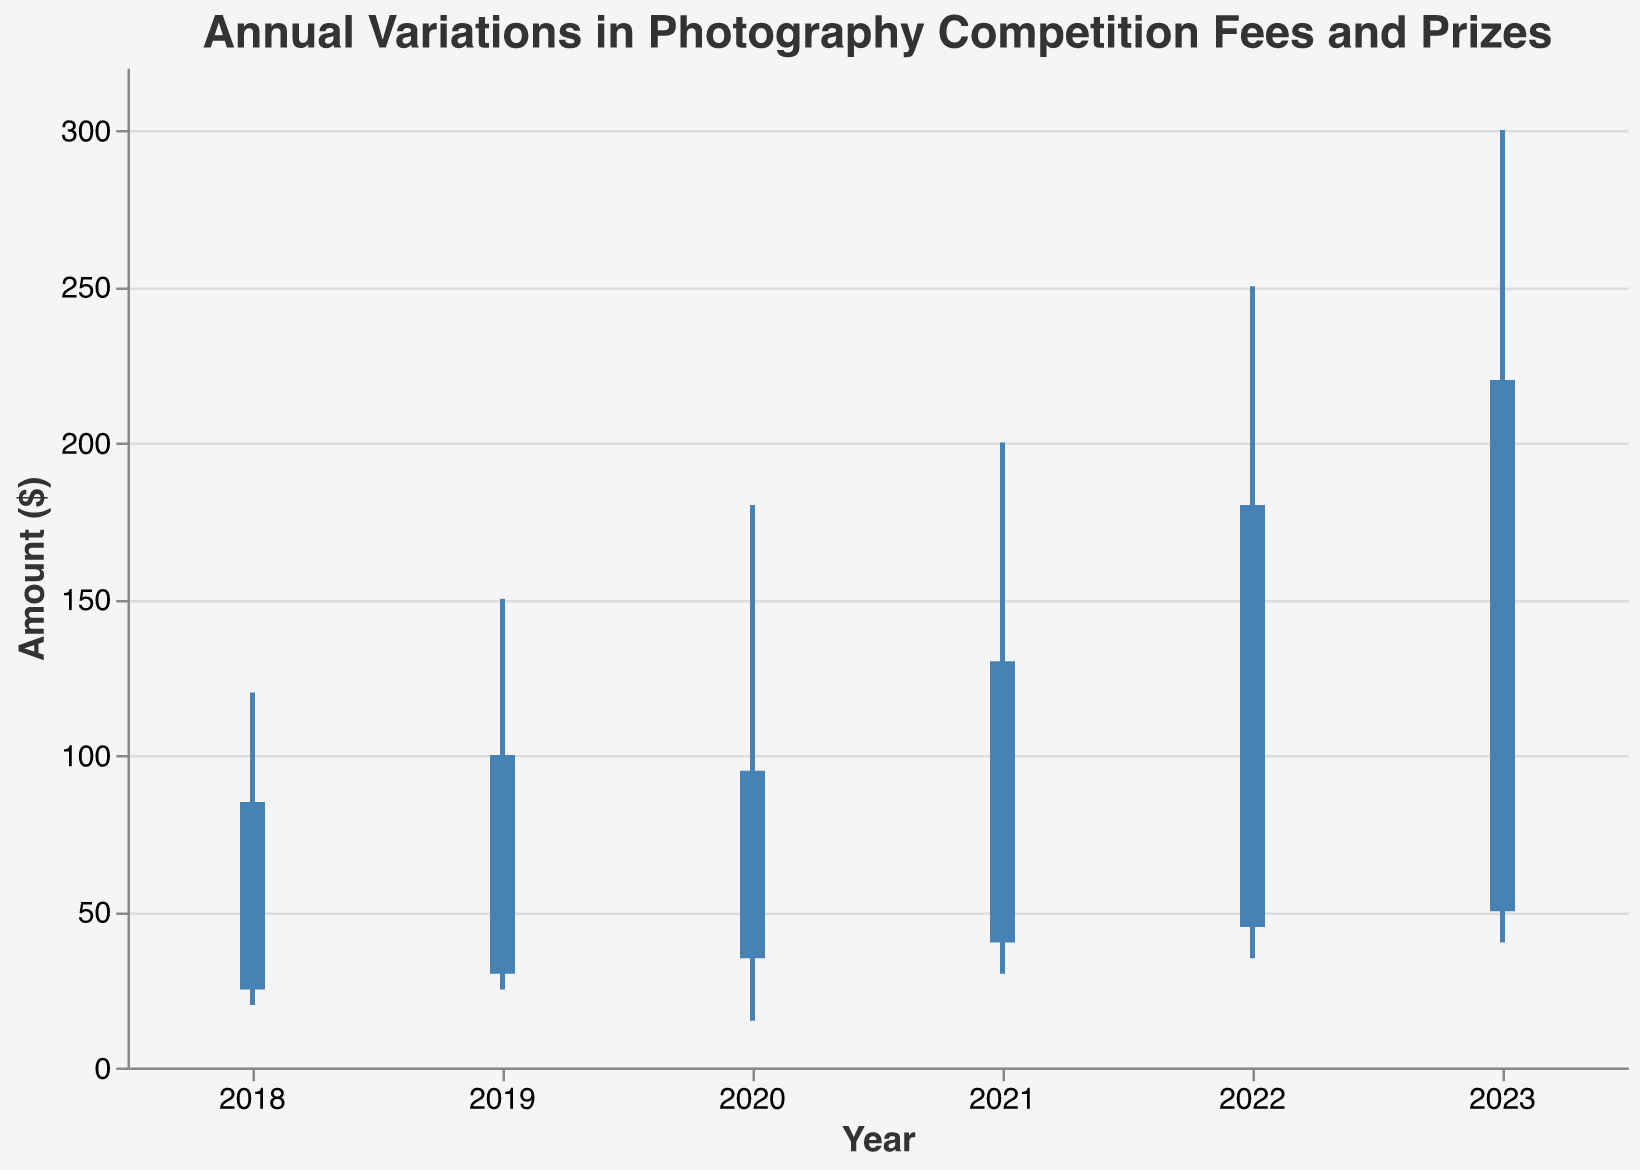What is the title of the figure? The title of the figure is at the top and reads "Annual Variations in Photography Competition Fees and Prizes."
Answer: Annual Variations in Photography Competition Fees and Prizes What colors are used for the elements in the figure? The main color used for the elements in the figure is blue (#4682B4). The axis titles and labels are in shades of dark gray (#333333), and the tick marks are in a lighter gray (#888888). The background is light gray (#F5F5F5).
Answer: Blue, dark gray, light gray How many years of data are presented in the figure? The x-axis labels show years from 2018 to 2023. Counting these, there are six years of data presented.
Answer: 6 What is the highest prize money noted in the figure, and in which year did it occur? The highest value on the y-axis, representing the prize money, is 300. This value is located on the bar for the year 2023.
Answer: 300, 2023 What was the closing value of the entry fee in 2021? The bar for the year 2021 reaches a closing value at the y-axis point of 130.
Answer: 130 Between which two years did the entry fee open at the same value? By observing the heights of the bars' starting points, the years 2022 and 2023 both open at the y-axis point of 45 and 50 respectively. However, since they are not identical, there are no years with the same opening values.
Answer: None What is the difference between the highest and lowest values in 2020? To find the range for the year 2020, subtract the lowest value (15) from the highest value (180). 180 - 15 = 165.
Answer: 165 In which year did the entry fee experience the lowest dip? The lowest value on the y-axis, representing the entry fee dip, is 15 which occurred in the year 2020.
Answer: 2020 How did the prize money trend over the years from 2018 to 2023? Observing the highest values on each bar from the left to the right (2018 to 2023), the prize money consistently increased each year: 120, 150, 180, 200, 250, and 300.
Answer: Consistently increased 